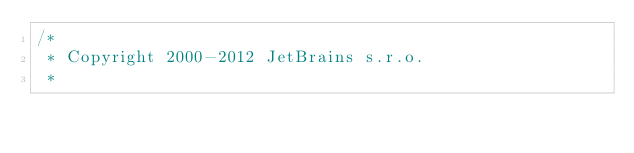Convert code to text. <code><loc_0><loc_0><loc_500><loc_500><_Java_>/*
 * Copyright 2000-2012 JetBrains s.r.o.
 *</code> 